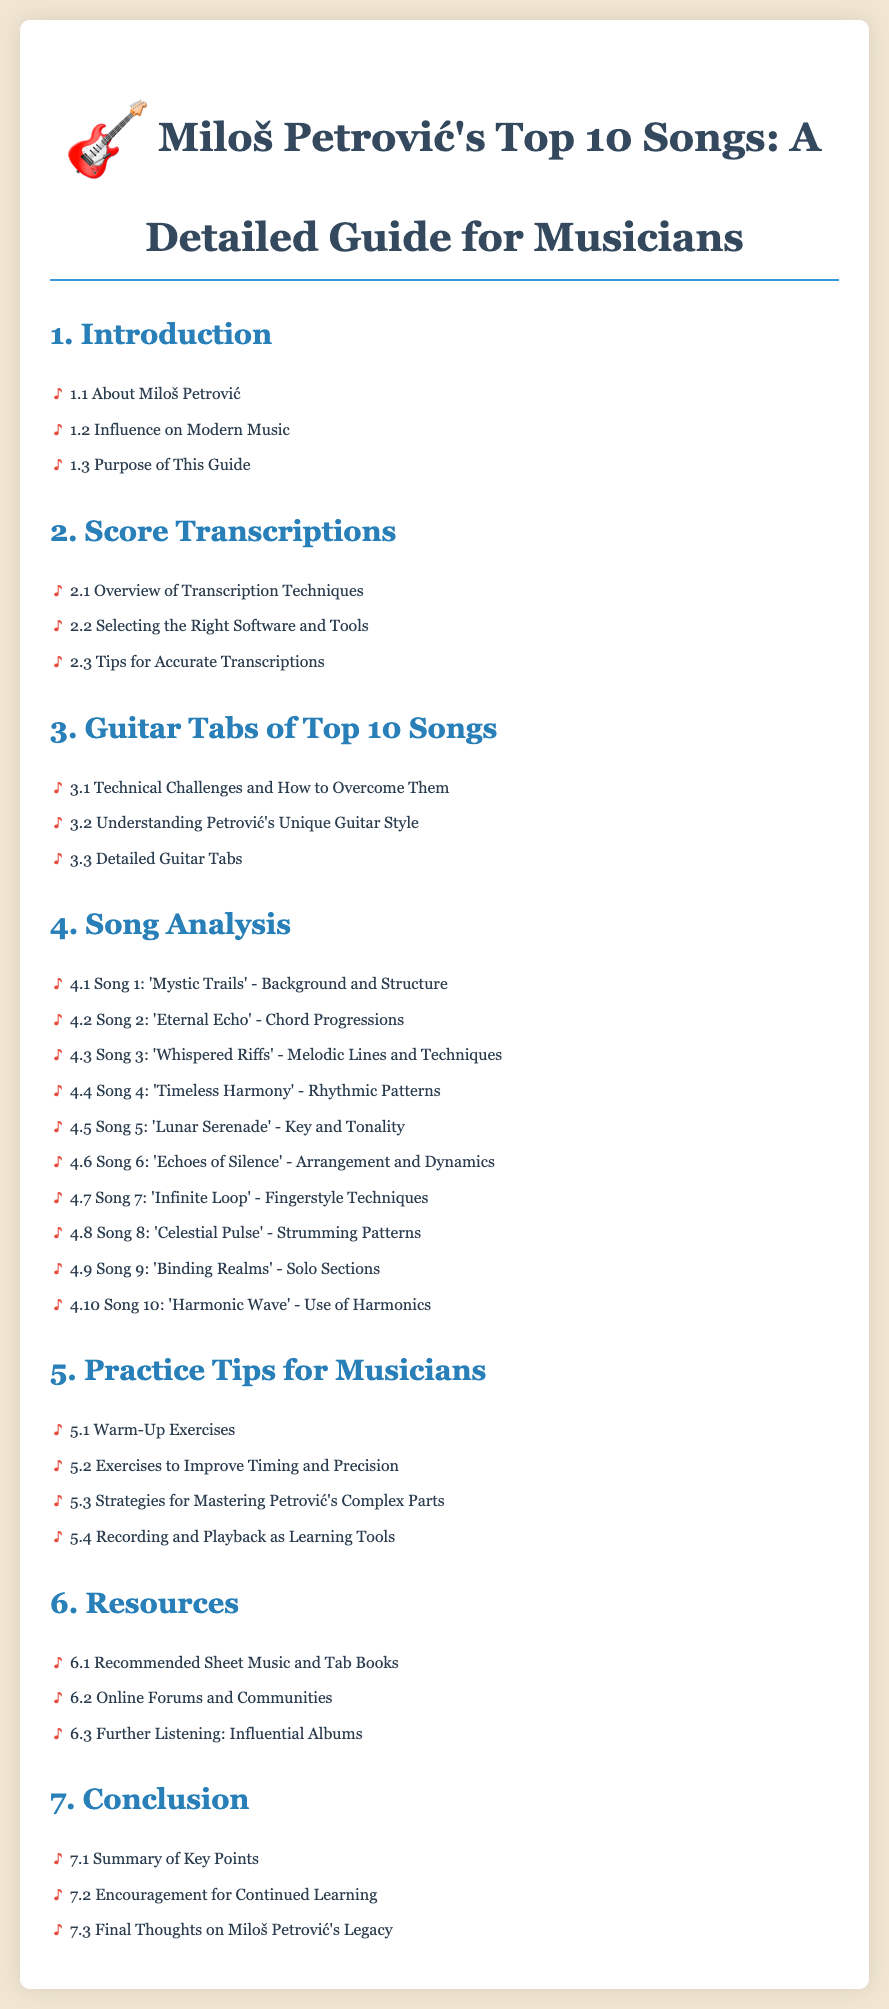What is the first section of the document? The first section listed in the table of contents is "Introduction."
Answer: Introduction How many songs are analyzed in the song analysis section? The song analysis section includes 10 songs.
Answer: 10 What subsection discusses transcription techniques? The subsection dedicated to transcription techniques is "Overview of Transcription Techniques."
Answer: Overview of Transcription Techniques Which song is analyzed for "Use of Harmonics"? The song analyzed for "Use of Harmonics" is "Harmonic Wave."
Answer: Harmonic Wave What is the main focus of section 5? Section 5 focuses on practice tips for musicians.
Answer: Practice Tips for Musicians What section comes after the "Score Transcriptions"? The section that comes after "Score Transcriptions" is "Guitar Tabs of Top 10 Songs."
Answer: Guitar Tabs of Top 10 Songs Which subsection gives tips for accurate transcriptions? The subsection that provides tips for accurate transcriptions is "Tips for Accurate Transcriptions."
Answer: Tips for Accurate Transcriptions How many practice tips are listed in section 5? There are four practice tips listed in section 5.
Answer: 4 What type of music does Miloš Petrović's music influence? The document states that it discusses the influence on modern music.
Answer: Modern Music 